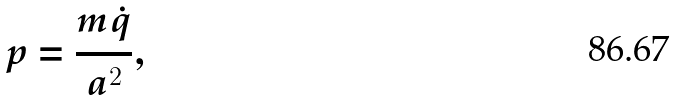<formula> <loc_0><loc_0><loc_500><loc_500>p = \frac { m \dot { q } } { a ^ { 2 } } ,</formula> 